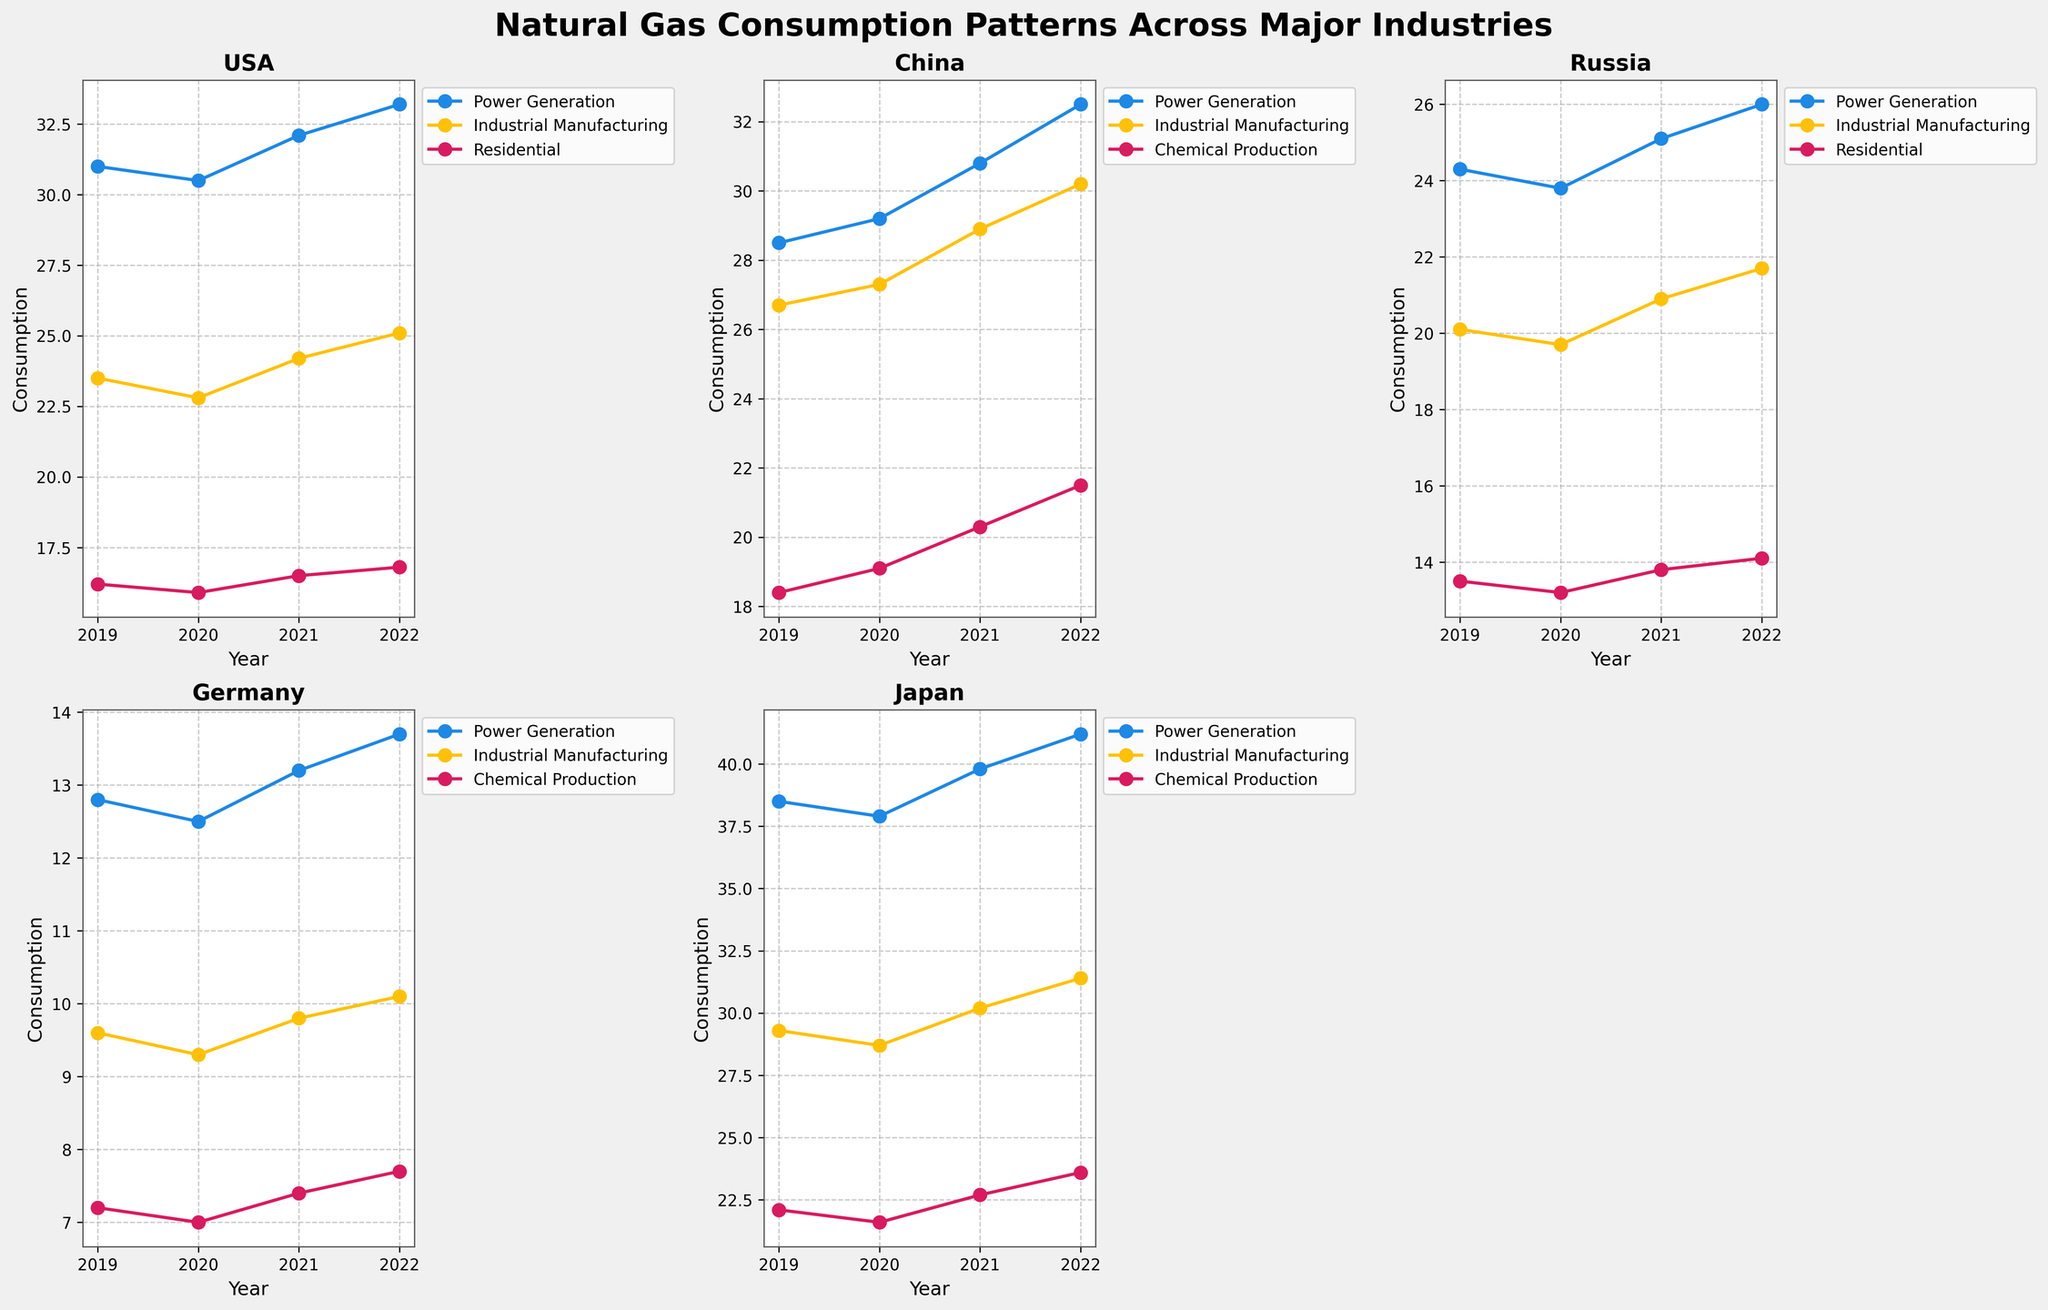What is the title of the overall figure? The title of the overall figure can be seen at the top of the plot. It is "Natural Gas Consumption Patterns Across Major Industries".
Answer: Natural Gas Consumption Patterns Across Major Industries Which country had the highest natural gas consumption for Power Generation in 2022? By looking at the subplots for each country, for the year 2022, Japan has the highest level for Power Generation.
Answer: Japan How does the natural gas consumption trend for Residential use in the USA compare to Russia from 2019 to 2022? For both countries, look at the Residential data points. In the USA, the trend is slightly increasing over the years. In Russia, it is relatively stable with a small increase.
Answer: USA: Slightly increasing, Russia: Relatively stable with a small increase What's the overall trend in natural gas consumption for Chemical Production in Germany from 2019 to 2022? By observing the Chemical Production line in the Germany subplot, the trend is slightly increasing each year.
Answer: Slightly increasing Which industry shows the most significant increase in natural gas consumption in China from 2019 to 2022? In the China subplot, compare the difference between the start and end points for each industry. Chemical Production has the most significant increase from 18.4 in 2019 to 21.5 in 2022.
Answer: Chemical Production In which country does Industrial Manufacturing consume more natural gas than Power Generation? By comparing the lines within each country's subplot, in China, Industrial Manufacturing consistently consumes more natural gas than Power Generation from 2019 to 2022.
Answer: China Which country has the smallest natural gas consumption for Industrial Manufacturing in 2019? Examine the Industrial Manufacturing lines for 2019 in each country's subplot. Germany has the smallest consumption which starts at 9.6.
Answer: Germany How does the natural gas consumption pattern for Power Generation in Germany compare to Japan over the years? By comparing the Power Generation lines in the Germany and Japan subplots, Japan consistently consumes much more natural gas across all years compared to Germany.
Answer: Japan consumes much more What's the percentage increase in natural gas consumption for Chemical Production in Japan from 2019 to 2022? For Japan, the Chemical Production values are 22.1 in 2019 and 23.6 in 2022. The percentage increase is calculated as ((23.6-22.1)/22.1)*100 = 6.79%.
Answer: 6.79% Which country showed the most considerable fluctuation in natural gas consumption for any industry from 2019 to 2022? Compare the up and down movements in the lines in each subplot, looking for the industry with the largest change in values. USA's Power Generation has noticeable fluctuations, increasing notably in 2021 and 2022.
Answer: USA (Power Generation) 